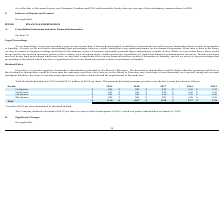According to Nordic American Tankers Limited's financial document, What is the amount of per share distributed as dividend-in-kind included in the 3rd quarter dividend in 2017? $0.05 per share distributed as dividend-in-kind. The document states: "* Includes $0.05 per share distributed as dividend-in-kind...." Also, What is the total dividends distributed in 2019? According to the financial document, $0.10. The relevant text states: "dends distributed in 2019 totaled $14.3 million or $0.10 per share. The quarterly dividend payments per share over the last 5 years have been as follows:..." Also, What is the value of total dividends distributed in 2019? According to the financial document, $14.3 million. The relevant text states: "Total dividends distributed in 2019 totaled $14.3 million or $0.10 per share. The quarterly dividend payments per share over the last 5 years have been as fol..." Also, can you calculate: What is the average quarterly dividend payments per share in the first quarter of 2018 and 2019? To answer this question, I need to perform calculations using the financial data. The calculation is: (0.03 + 0.04)/2 , which equals 0.04. This is based on the information: "1st Quarter $ 0.04 $ 0.03 $ 0.20 $ 0.43 $ 0.22 1st Quarter $ 0.04 $ 0.03 $ 0.20 $ 0.43 $ 0.22..." The key data points involved are: 0.03. Also, can you calculate: What is the average quarterly dividend payments per share in the second quarter of 2018 and 2019? To answer this question, I need to perform calculations using the financial data. The calculation is: (0.03 + 0.01)/2 , which equals 0.02. This is based on the information: "1st Quarter $ 0.04 $ 0.03 $ 0.20 $ 0.43 $ 0.22 2nd Quarter $ 0.03 $ 0.01 $ 0.20 $ 0.43 $ 0.38..." The key data points involved are: 0.01, 0.03. Also, can you calculate: What is the average quarterly dividend payments per share in the third quarter of 2018 and 2019? To answer this question, I need to perform calculations using the financial data. The calculation is: (0.01 + 0.02)/2 , which equals 0.01. This is based on the information: "3rd Quarter $ 0.01 $ 0.02 $ 0.15* $ 0.25 $ 0.40 2nd Quarter $ 0.03 $ 0.01 $ 0.20 $ 0.43 $ 0.38..." The key data points involved are: 0.02. 